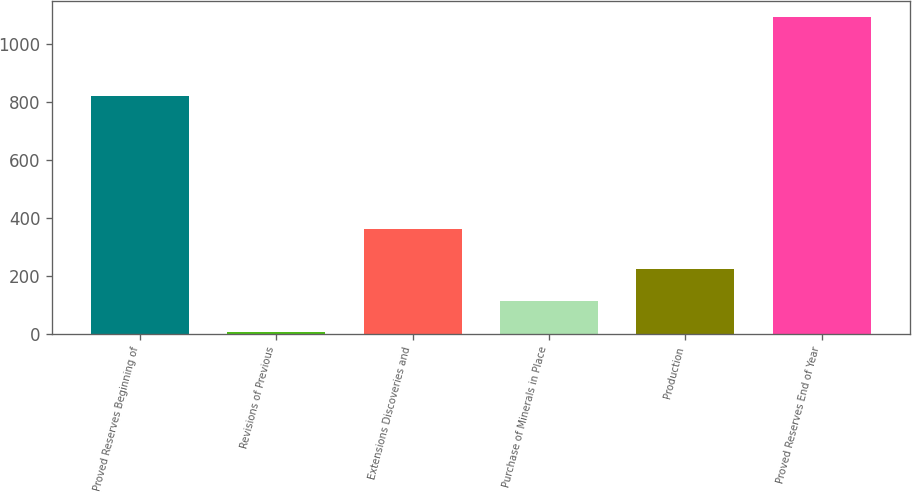Convert chart to OTSL. <chart><loc_0><loc_0><loc_500><loc_500><bar_chart><fcel>Proved Reserves Beginning of<fcel>Revisions of Previous<fcel>Extensions Discoveries and<fcel>Purchase of Minerals in Place<fcel>Production<fcel>Proved Reserves End of Year<nl><fcel>820<fcel>5<fcel>360<fcel>113.7<fcel>222.4<fcel>1092<nl></chart> 